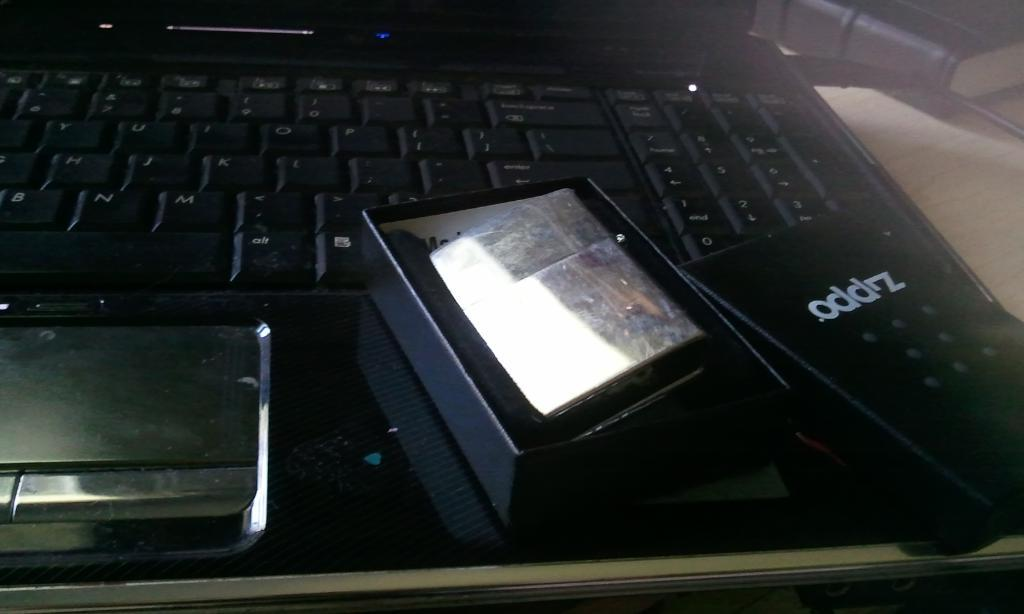<image>
Write a terse but informative summary of the picture. A Zippo brand lighter is in a black box on top of a laptop. 